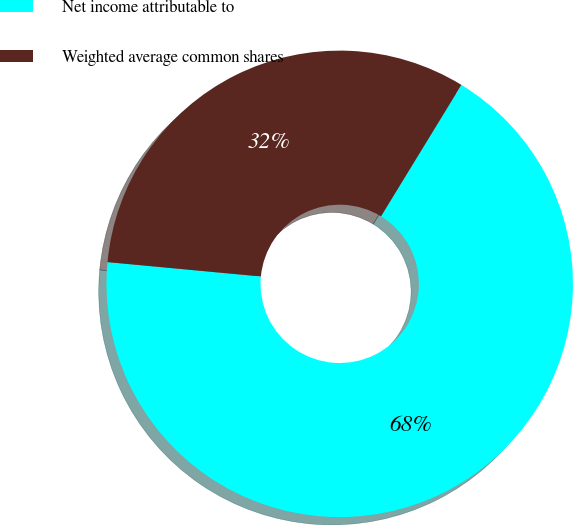Convert chart to OTSL. <chart><loc_0><loc_0><loc_500><loc_500><pie_chart><fcel>Net income attributable to<fcel>Weighted average common shares<nl><fcel>67.75%<fcel>32.25%<nl></chart> 